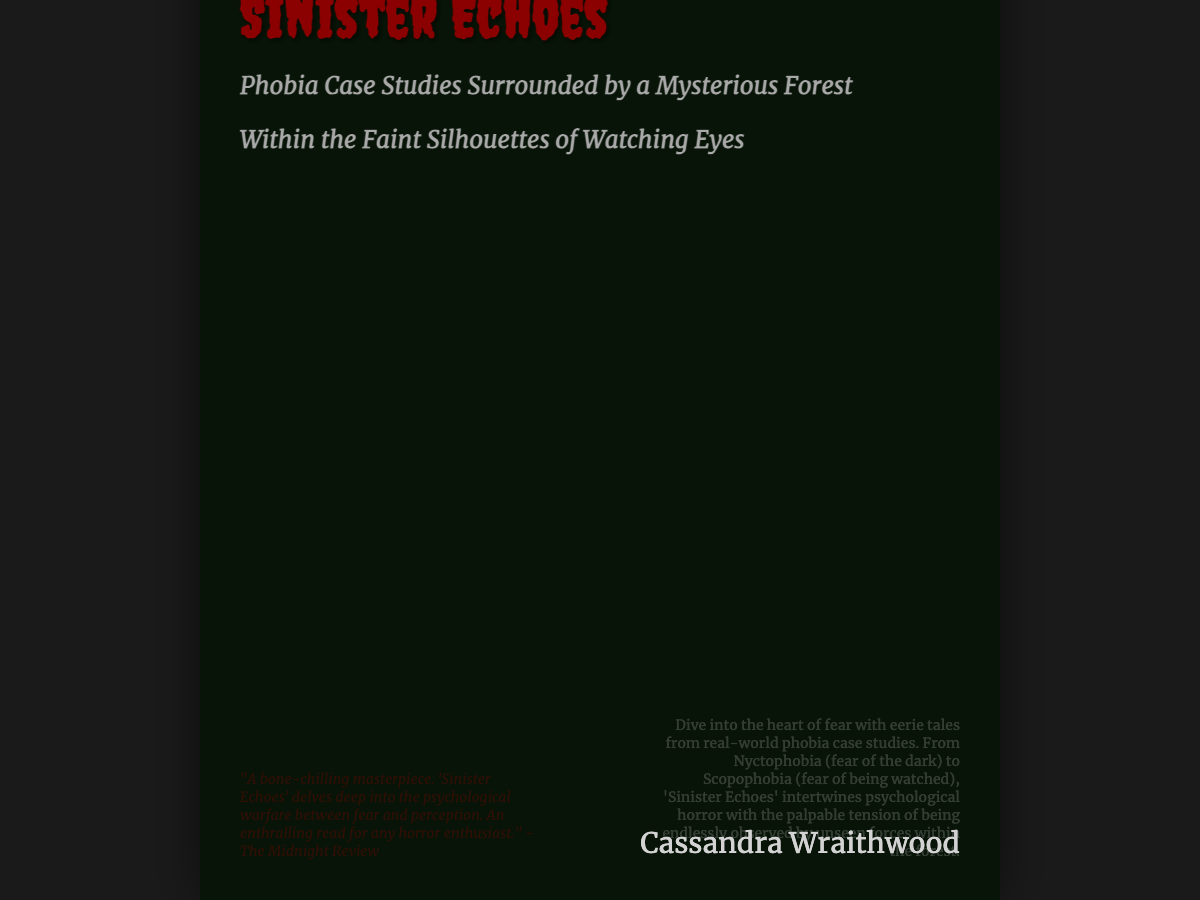What is the title of the book? The title is prominently displayed at the top of the document cover.
Answer: Sinister Echoes Who is the author of the book? The author's name is listed at the bottom right of the cover.
Answer: Cassandra Wraithwood What is the subtitle of the book? The subtitle provides additional context about the book's content.
Answer: Phobia Case Studies Surrounded by a Mysterious Forest What type of phobia is specifically mentioned in the description? The description lists examples of phobias covered in the book, including one notable case.
Answer: Nyctophobia What color is the title of the book? The book title's color is distinctly shown in the title's styling.
Answer: dark red What theme does the book cover highlight? The overall visual elements and text suggest a heavy emphasis on fear and observation.
Answer: Psychological horror How many subtitles are there on the cover? The cover contains a main subtitle and an additional descriptive subtitle beneath it.
Answer: Two What artistic style is the title written in? The title uses a specific font style known for its thematic association with horror.
Answer: Creepster What does the back cover provide about the book? The back cover offers a brief synopsis or lure to attract readers' interest.
Answer: A description of phobia case studies within the narrative 